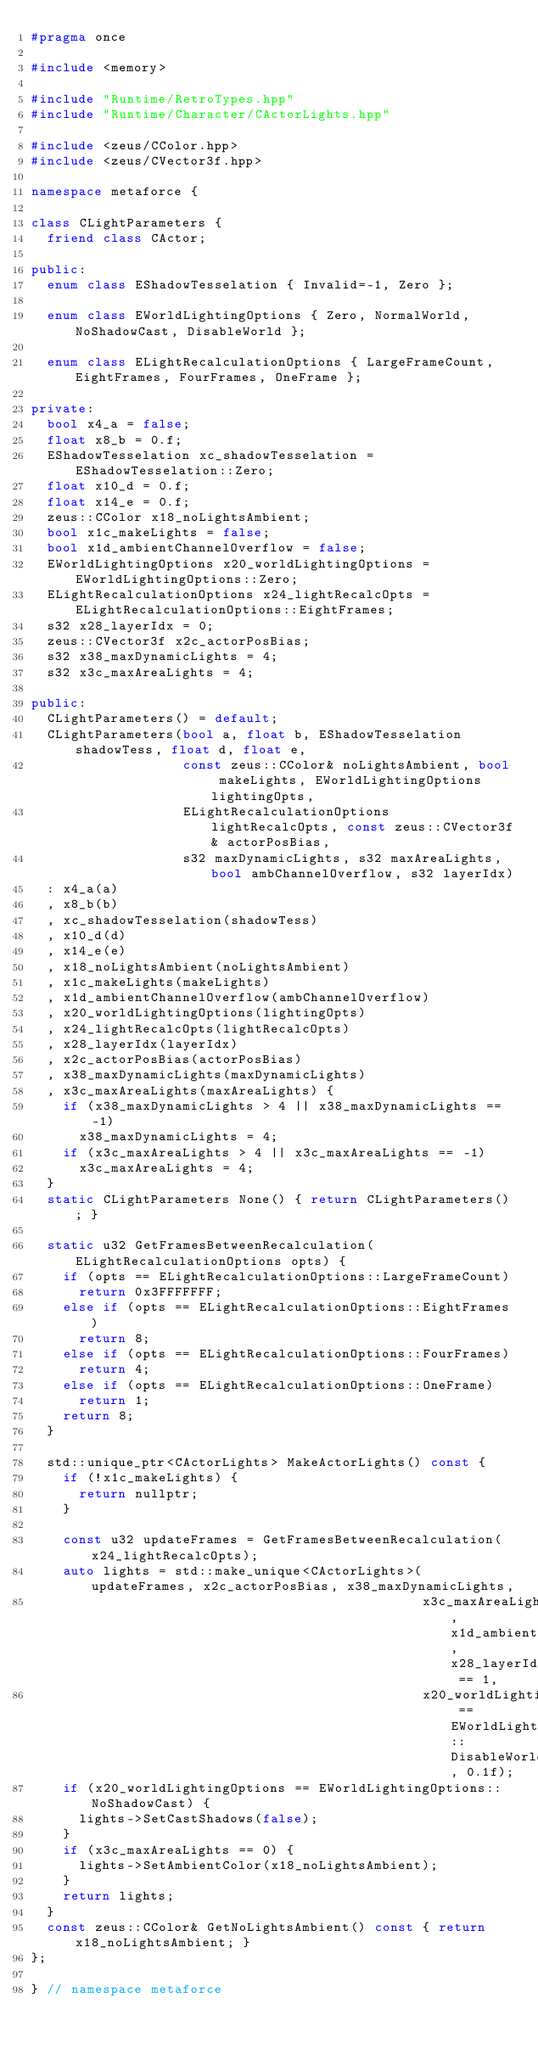Convert code to text. <code><loc_0><loc_0><loc_500><loc_500><_C++_>#pragma once

#include <memory>

#include "Runtime/RetroTypes.hpp"
#include "Runtime/Character/CActorLights.hpp"

#include <zeus/CColor.hpp>
#include <zeus/CVector3f.hpp>

namespace metaforce {

class CLightParameters {
  friend class CActor;

public:
  enum class EShadowTesselation { Invalid=-1, Zero };

  enum class EWorldLightingOptions { Zero, NormalWorld, NoShadowCast, DisableWorld };

  enum class ELightRecalculationOptions { LargeFrameCount, EightFrames, FourFrames, OneFrame };

private:
  bool x4_a = false;
  float x8_b = 0.f;
  EShadowTesselation xc_shadowTesselation = EShadowTesselation::Zero;
  float x10_d = 0.f;
  float x14_e = 0.f;
  zeus::CColor x18_noLightsAmbient;
  bool x1c_makeLights = false;
  bool x1d_ambientChannelOverflow = false;
  EWorldLightingOptions x20_worldLightingOptions = EWorldLightingOptions::Zero;
  ELightRecalculationOptions x24_lightRecalcOpts = ELightRecalculationOptions::EightFrames;
  s32 x28_layerIdx = 0;
  zeus::CVector3f x2c_actorPosBias;
  s32 x38_maxDynamicLights = 4;
  s32 x3c_maxAreaLights = 4;

public:
  CLightParameters() = default;
  CLightParameters(bool a, float b, EShadowTesselation shadowTess, float d, float e,
                   const zeus::CColor& noLightsAmbient, bool makeLights, EWorldLightingOptions lightingOpts,
                   ELightRecalculationOptions lightRecalcOpts, const zeus::CVector3f& actorPosBias,
                   s32 maxDynamicLights, s32 maxAreaLights, bool ambChannelOverflow, s32 layerIdx)
  : x4_a(a)
  , x8_b(b)
  , xc_shadowTesselation(shadowTess)
  , x10_d(d)
  , x14_e(e)
  , x18_noLightsAmbient(noLightsAmbient)
  , x1c_makeLights(makeLights)
  , x1d_ambientChannelOverflow(ambChannelOverflow)
  , x20_worldLightingOptions(lightingOpts)
  , x24_lightRecalcOpts(lightRecalcOpts)
  , x28_layerIdx(layerIdx)
  , x2c_actorPosBias(actorPosBias)
  , x38_maxDynamicLights(maxDynamicLights)
  , x3c_maxAreaLights(maxAreaLights) {
    if (x38_maxDynamicLights > 4 || x38_maxDynamicLights == -1)
      x38_maxDynamicLights = 4;
    if (x3c_maxAreaLights > 4 || x3c_maxAreaLights == -1)
      x3c_maxAreaLights = 4;
  }
  static CLightParameters None() { return CLightParameters(); }

  static u32 GetFramesBetweenRecalculation(ELightRecalculationOptions opts) {
    if (opts == ELightRecalculationOptions::LargeFrameCount)
      return 0x3FFFFFFF;
    else if (opts == ELightRecalculationOptions::EightFrames)
      return 8;
    else if (opts == ELightRecalculationOptions::FourFrames)
      return 4;
    else if (opts == ELightRecalculationOptions::OneFrame)
      return 1;
    return 8;
  }

  std::unique_ptr<CActorLights> MakeActorLights() const {
    if (!x1c_makeLights) {
      return nullptr;
    }

    const u32 updateFrames = GetFramesBetweenRecalculation(x24_lightRecalcOpts);
    auto lights = std::make_unique<CActorLights>(updateFrames, x2c_actorPosBias, x38_maxDynamicLights,
                                                 x3c_maxAreaLights, x1d_ambientChannelOverflow, x28_layerIdx == 1,
                                                 x20_worldLightingOptions == EWorldLightingOptions::DisableWorld, 0.1f);
    if (x20_worldLightingOptions == EWorldLightingOptions::NoShadowCast) {
      lights->SetCastShadows(false);
    }
    if (x3c_maxAreaLights == 0) {
      lights->SetAmbientColor(x18_noLightsAmbient);
    }
    return lights;
  }
  const zeus::CColor& GetNoLightsAmbient() const { return x18_noLightsAmbient; }
};

} // namespace metaforce
</code> 